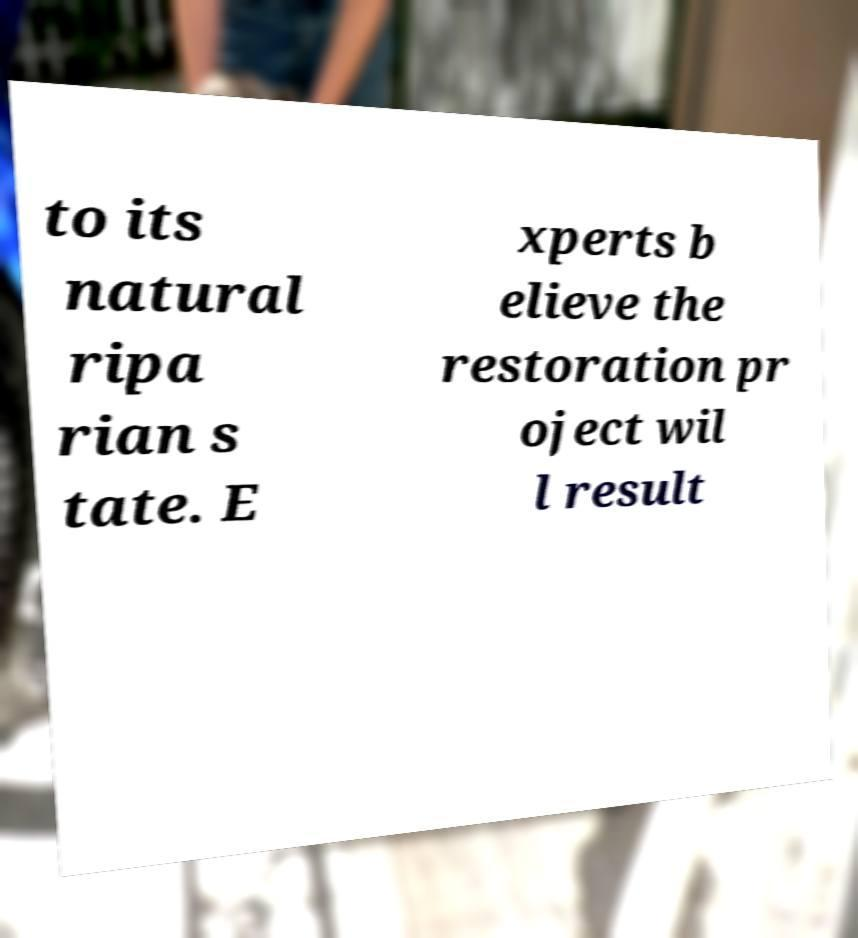Could you assist in decoding the text presented in this image and type it out clearly? to its natural ripa rian s tate. E xperts b elieve the restoration pr oject wil l result 